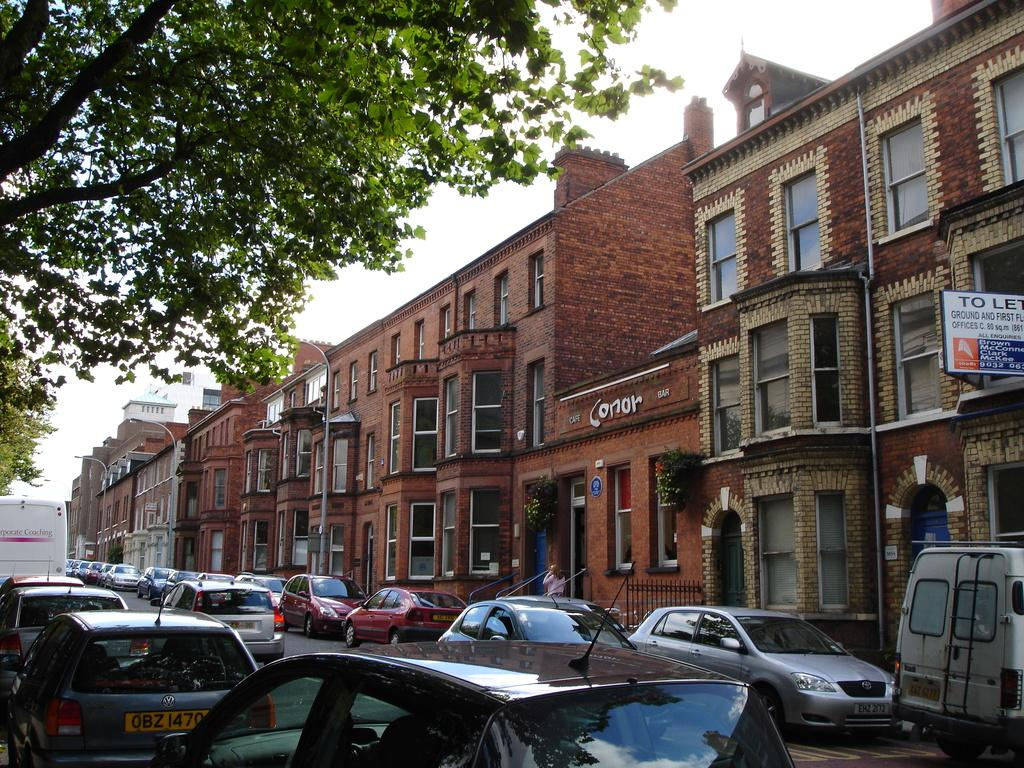<image>
Summarize the visual content of the image. Short building named Cafe Conor Bar in between a row of other buildings. 